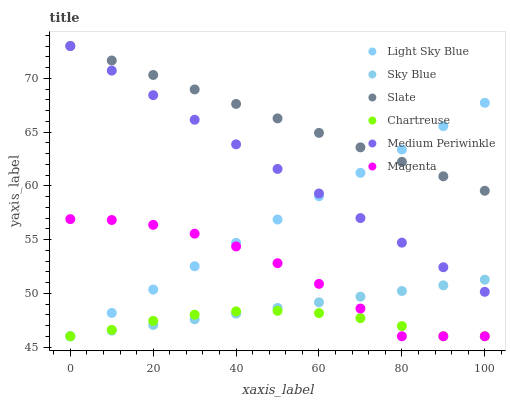Does Chartreuse have the minimum area under the curve?
Answer yes or no. Yes. Does Slate have the maximum area under the curve?
Answer yes or no. Yes. Does Medium Periwinkle have the minimum area under the curve?
Answer yes or no. No. Does Medium Periwinkle have the maximum area under the curve?
Answer yes or no. No. Is Slate the smoothest?
Answer yes or no. Yes. Is Magenta the roughest?
Answer yes or no. Yes. Is Chartreuse the smoothest?
Answer yes or no. No. Is Chartreuse the roughest?
Answer yes or no. No. Does Chartreuse have the lowest value?
Answer yes or no. Yes. Does Medium Periwinkle have the lowest value?
Answer yes or no. No. Does Medium Periwinkle have the highest value?
Answer yes or no. Yes. Does Chartreuse have the highest value?
Answer yes or no. No. Is Magenta less than Medium Periwinkle?
Answer yes or no. Yes. Is Slate greater than Sky Blue?
Answer yes or no. Yes. Does Medium Periwinkle intersect Sky Blue?
Answer yes or no. Yes. Is Medium Periwinkle less than Sky Blue?
Answer yes or no. No. Is Medium Periwinkle greater than Sky Blue?
Answer yes or no. No. Does Magenta intersect Medium Periwinkle?
Answer yes or no. No. 